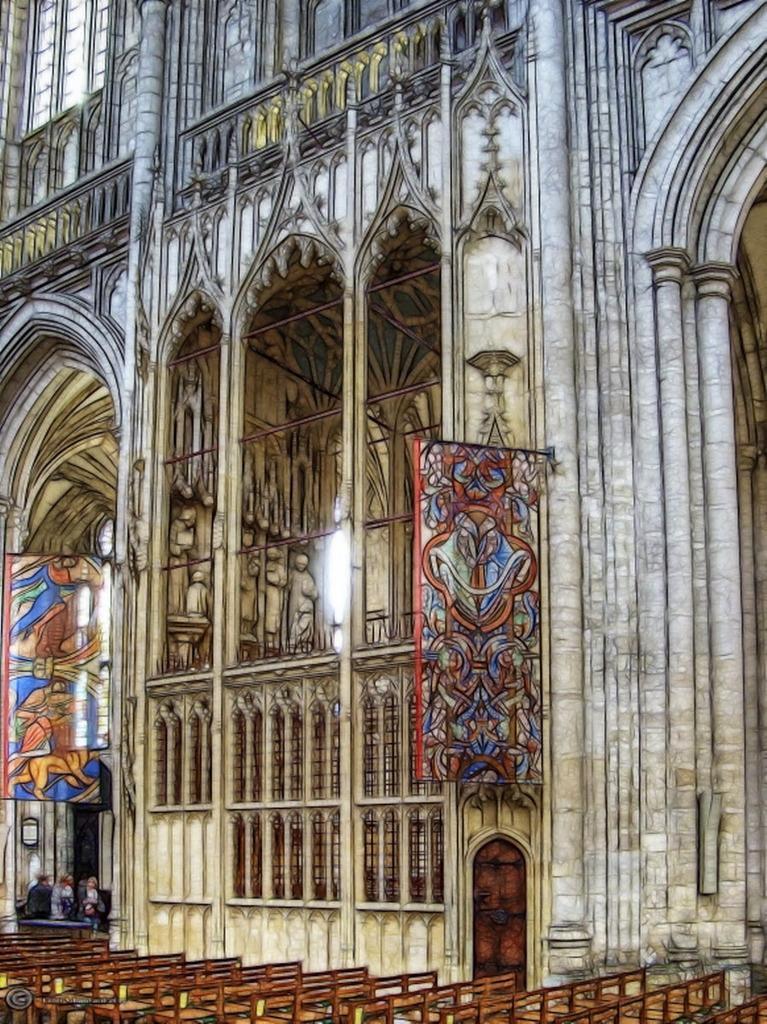In one or two sentences, can you explain what this image depicts? On the bottom we can see many benches. On the bottom left there is group of person standing near to the door. Here we can see painting frames. On the top we can see a monument. This picture looks like a painting. 